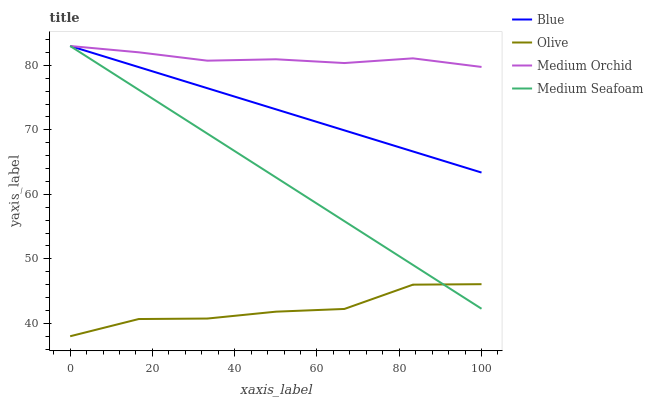Does Olive have the minimum area under the curve?
Answer yes or no. Yes. Does Medium Orchid have the maximum area under the curve?
Answer yes or no. Yes. Does Medium Orchid have the minimum area under the curve?
Answer yes or no. No. Does Olive have the maximum area under the curve?
Answer yes or no. No. Is Medium Seafoam the smoothest?
Answer yes or no. Yes. Is Olive the roughest?
Answer yes or no. Yes. Is Medium Orchid the smoothest?
Answer yes or no. No. Is Medium Orchid the roughest?
Answer yes or no. No. Does Olive have the lowest value?
Answer yes or no. Yes. Does Medium Orchid have the lowest value?
Answer yes or no. No. Does Medium Seafoam have the highest value?
Answer yes or no. Yes. Does Olive have the highest value?
Answer yes or no. No. Is Olive less than Medium Orchid?
Answer yes or no. Yes. Is Medium Orchid greater than Olive?
Answer yes or no. Yes. Does Medium Seafoam intersect Blue?
Answer yes or no. Yes. Is Medium Seafoam less than Blue?
Answer yes or no. No. Is Medium Seafoam greater than Blue?
Answer yes or no. No. Does Olive intersect Medium Orchid?
Answer yes or no. No. 